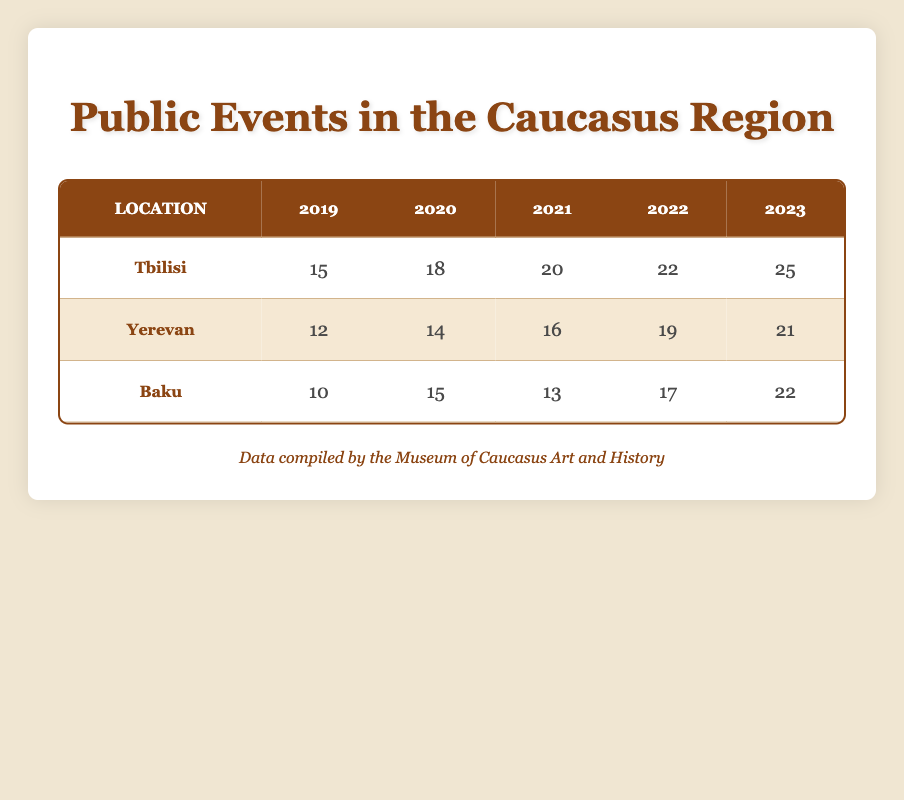What was the total number of public events held in Tbilisi in 2020? In the table, the event count for Tbilisi in 2020 is listed as 18. So, that is the total number of public events for that year in that location.
Answer: 18 Which city had the highest number of public events in 2022? Looking at the event counts for 2022, Tbilisi has 22 events, Yerevan has 19, and Baku has 17. Since 22 is the highest value among these, Tbilisi had the most events.
Answer: Tbilisi Did Baku have more public events in 2021 than in 2020? For Baku, the event count in 2021 is recorded as 13, while in 2020 it is 15. Since 13 is less than 15, Baku did not have more events in 2021 compared to 2020.
Answer: No What is the total number of public events held across all three locations in 2023? The event counts for 2023 are Tbilisi (25), Yerevan (21), and Baku (22). Adding these together gives 25 + 21 + 22 = 68, which is the total for all locations in that year.
Answer: 68 How many more public events were held in Yerevan in 2022 compared to 2019? For Yerevan, the event counts are 19 in 2022 and 12 in 2019. To find the difference, subtract the 2019 count from the 2022 count: 19 - 12 = 7. Therefore, there were 7 more events in 2022 than in 2019.
Answer: 7 Which location saw the highest increase in public events from 2019 to 2023? First, we find the event count for each location in both years. Tbilisi increased from 15 to 25 (10 events), Yerevan from 12 to 21 (9 events), and Baku from 10 to 22 (12 events). The highest increase is in Baku with an increase of 12 events.
Answer: Baku Was there a steady increase in the number of events for Tbilisi from 2019 to 2023? Checking the events for Tbilisi: 15 in 2019, 18 in 2020, 20 in 2021, 22 in 2022, and 25 in 2023. All values increase over the years, showing a steady increase.
Answer: Yes How many events did Baku host in total over the years listed? The counts for Baku are 10 (2019), 15 (2020), 13 (2021), 17 (2022), and 22 (2023). Adding these gives: 10 + 15 + 13 + 17 + 22 = 77. This sum is the total number of events hosted in Baku.
Answer: 77 